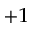<formula> <loc_0><loc_0><loc_500><loc_500>_ { + 1 }</formula> 